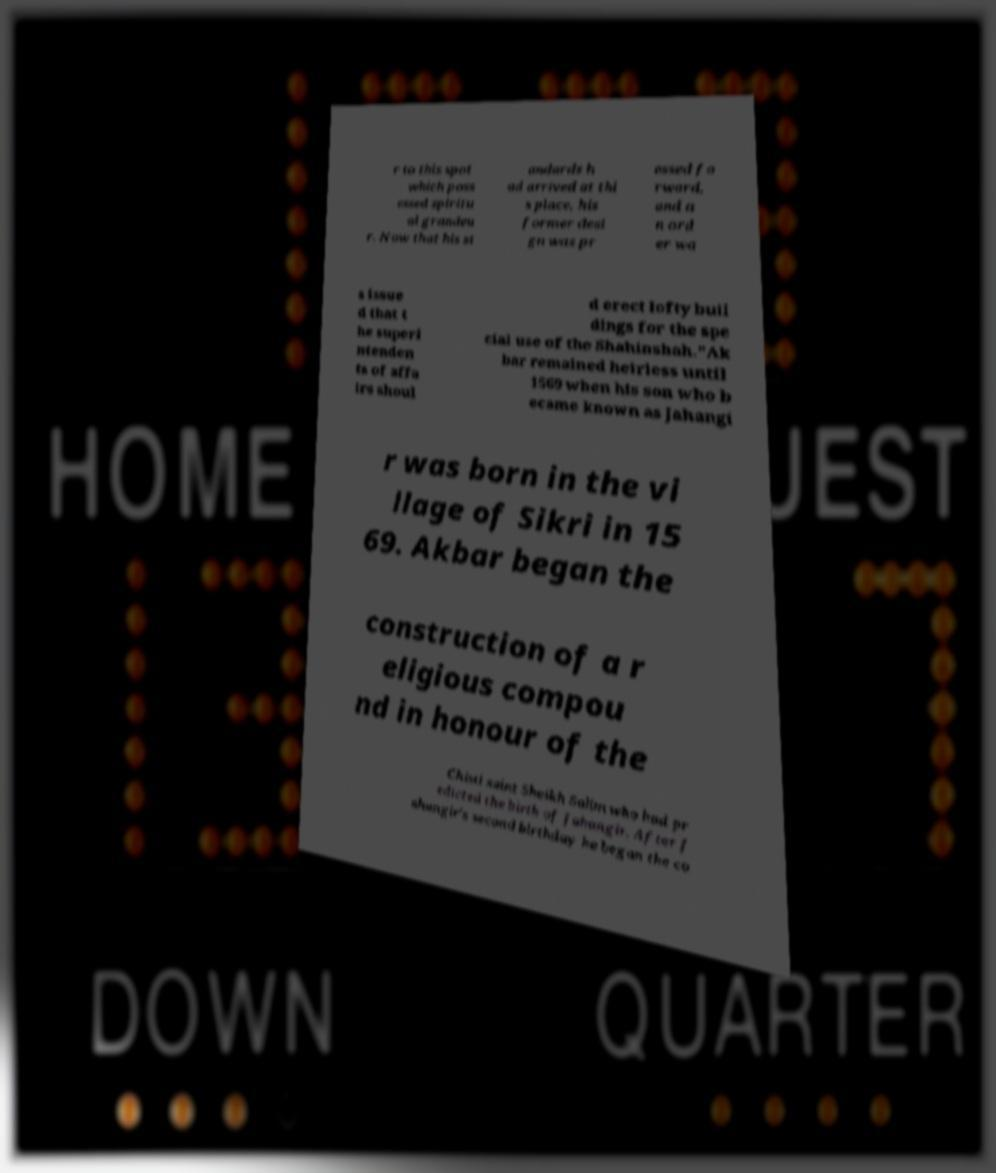Please read and relay the text visible in this image. What does it say? r to this spot which poss essed spiritu al grandeu r. Now that his st andards h ad arrived at thi s place, his former desi gn was pr essed fo rward, and a n ord er wa s issue d that t he superi ntenden ts of affa irs shoul d erect lofty buil dings for the spe cial use of the Shahinshah."Ak bar remained heirless until 1569 when his son who b ecame known as Jahangi r was born in the vi llage of Sikri in 15 69. Akbar began the construction of a r eligious compou nd in honour of the Chisti saint Sheikh Salim who had pr edicted the birth of Jahangir. After J ahangir's second birthday he began the co 